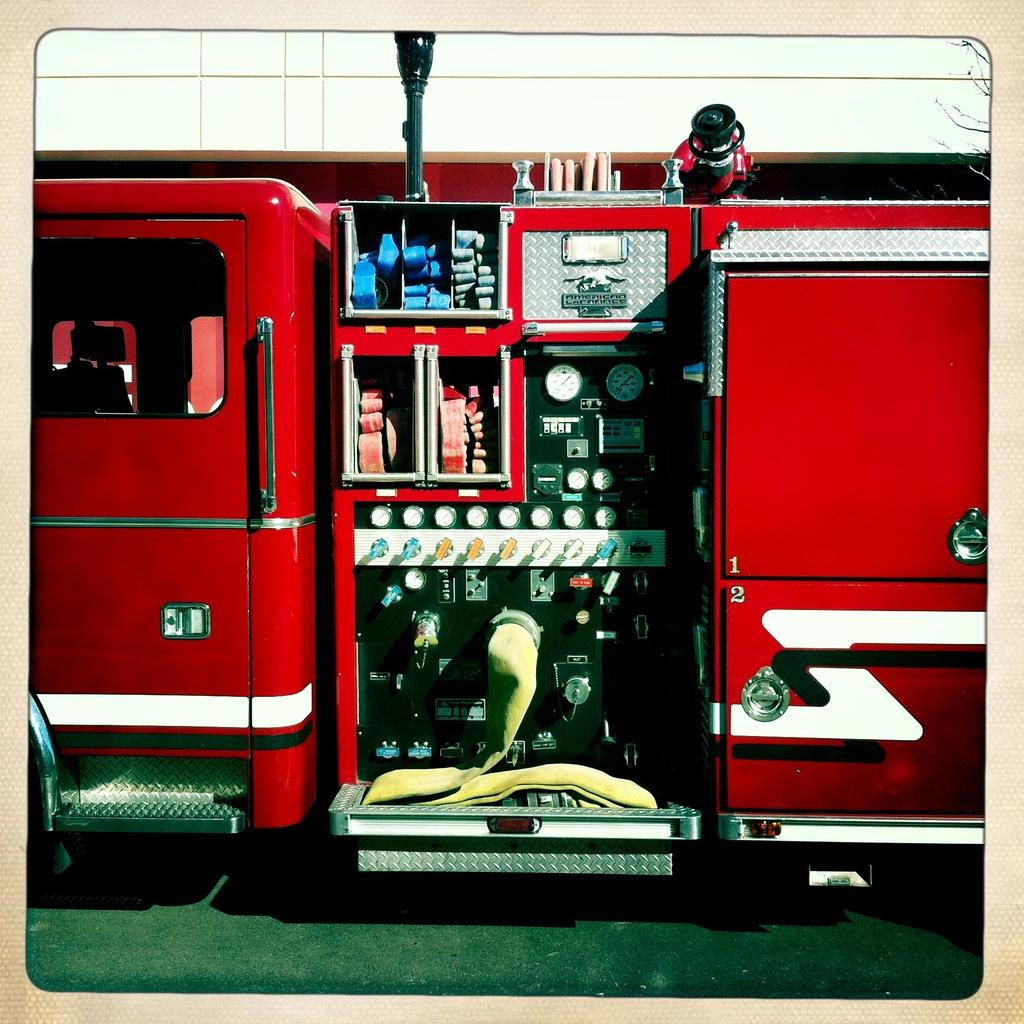What is the main subject of the image? There is a fire engine in the image. What other objects can be seen in the image? There are meters, a pipe, a door, and a window in the image. What type of flowers are growing near the fire engine in the image? There are no flowers present in the image; it only features a fire engine, meters, a pipe, a door, and a window. 